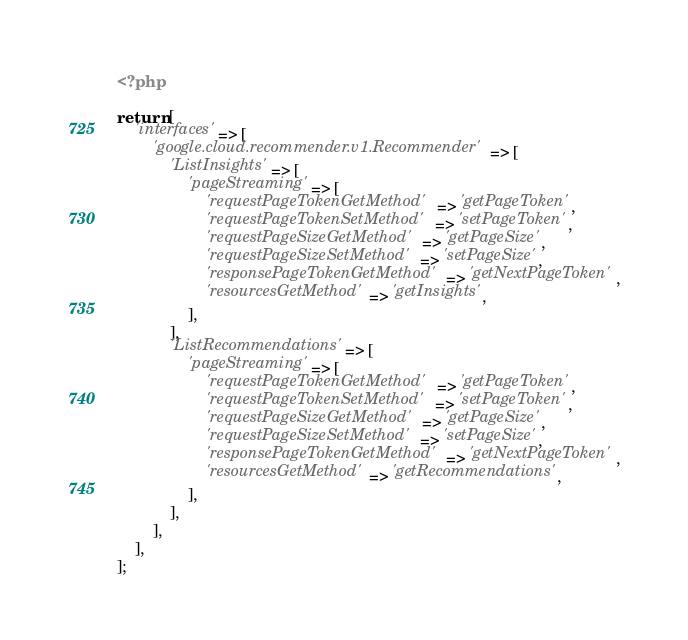<code> <loc_0><loc_0><loc_500><loc_500><_PHP_><?php

return [
    'interfaces' => [
        'google.cloud.recommender.v1.Recommender' => [
            'ListInsights' => [
                'pageStreaming' => [
                    'requestPageTokenGetMethod' => 'getPageToken',
                    'requestPageTokenSetMethod' => 'setPageToken',
                    'requestPageSizeGetMethod' => 'getPageSize',
                    'requestPageSizeSetMethod' => 'setPageSize',
                    'responsePageTokenGetMethod' => 'getNextPageToken',
                    'resourcesGetMethod' => 'getInsights',
                ],
            ],
            'ListRecommendations' => [
                'pageStreaming' => [
                    'requestPageTokenGetMethod' => 'getPageToken',
                    'requestPageTokenSetMethod' => 'setPageToken',
                    'requestPageSizeGetMethod' => 'getPageSize',
                    'requestPageSizeSetMethod' => 'setPageSize',
                    'responsePageTokenGetMethod' => 'getNextPageToken',
                    'resourcesGetMethod' => 'getRecommendations',
                ],
            ],
        ],
    ],
];
</code> 